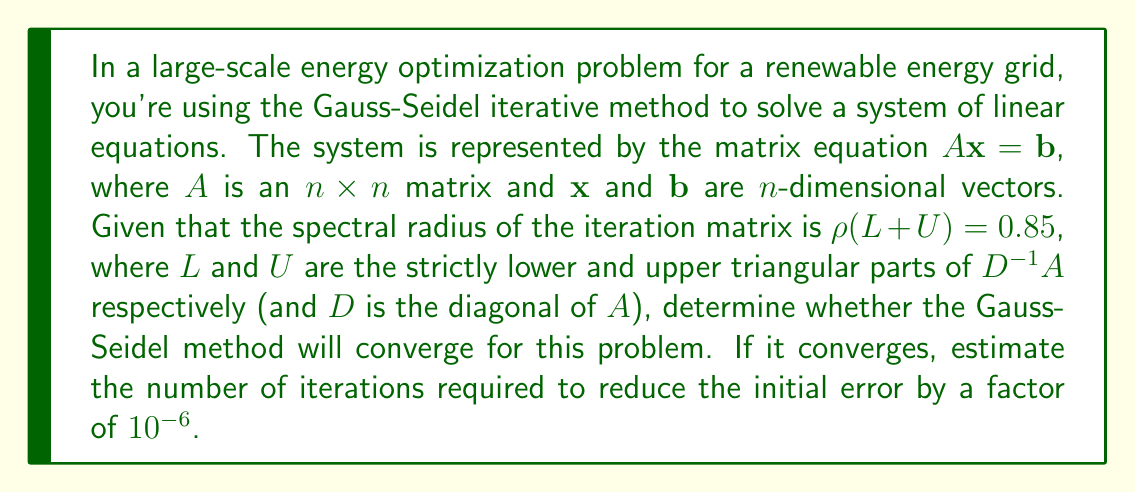Can you answer this question? To solve this problem, we need to follow these steps:

1) First, recall the convergence criterion for the Gauss-Seidel method:
   The method converges if and only if $\rho(L + U) < 1$, where $\rho$ is the spectral radius.

2) We're given that $\rho(L + U) = 0.85$. Since $0.85 < 1$, the Gauss-Seidel method will converge for this problem.

3) To estimate the number of iterations, we can use the following formula:
   $$k \approx \frac{\log(\epsilon)}{\log(\rho(L + U))}$$
   where $k$ is the number of iterations, $\epsilon$ is the desired reduction in error, and $\rho(L + U)$ is the spectral radius of the iteration matrix.

4) We want to reduce the error by a factor of $10^{-6}$, so $\epsilon = 10^{-6}$.

5) Plugging in the values:
   $$k \approx \frac{\log(10^{-6})}{\log(0.85)}$$

6) Calculating:
   $$k \approx \frac{-6 \log(10)}{\log(0.85)} \approx \frac{-13.8155}{-0.1625} \approx 85.02$$

7) Since we need a whole number of iterations, we round up to the next integer.
Answer: Yes, the Gauss-Seidel method will converge for this problem since $\rho(L + U) = 0.85 < 1$. The method will require approximately 86 iterations to reduce the initial error by a factor of $10^{-6}$. 